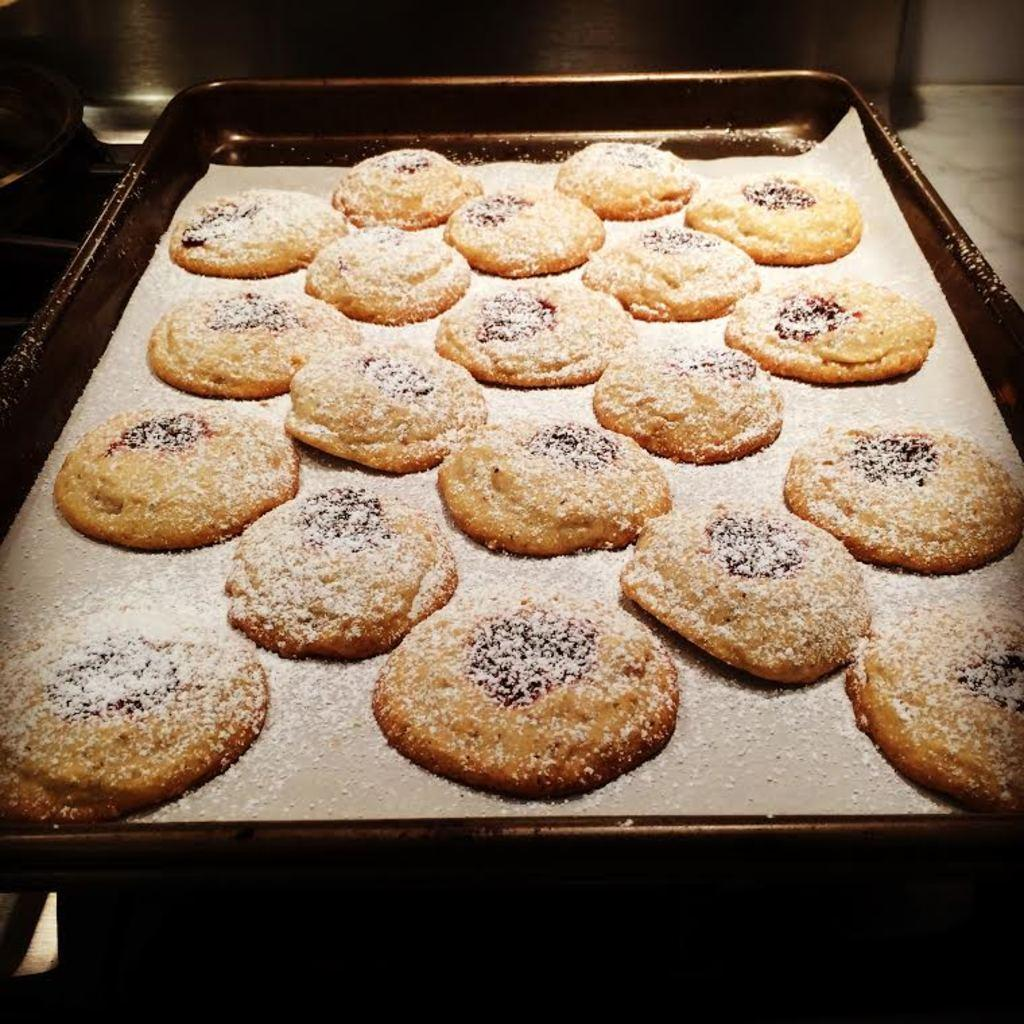What type of food can be seen in the image? There are cookies in the image. What is covering the cookies? The cookies are sprinkled with powder. How are the cookies arranged in the image? The cookies are in a tray. Can you hear the cookies crying in the image? There are no sounds or emotions associated with the cookies in the image, so it is not possible to determine if they are crying. 